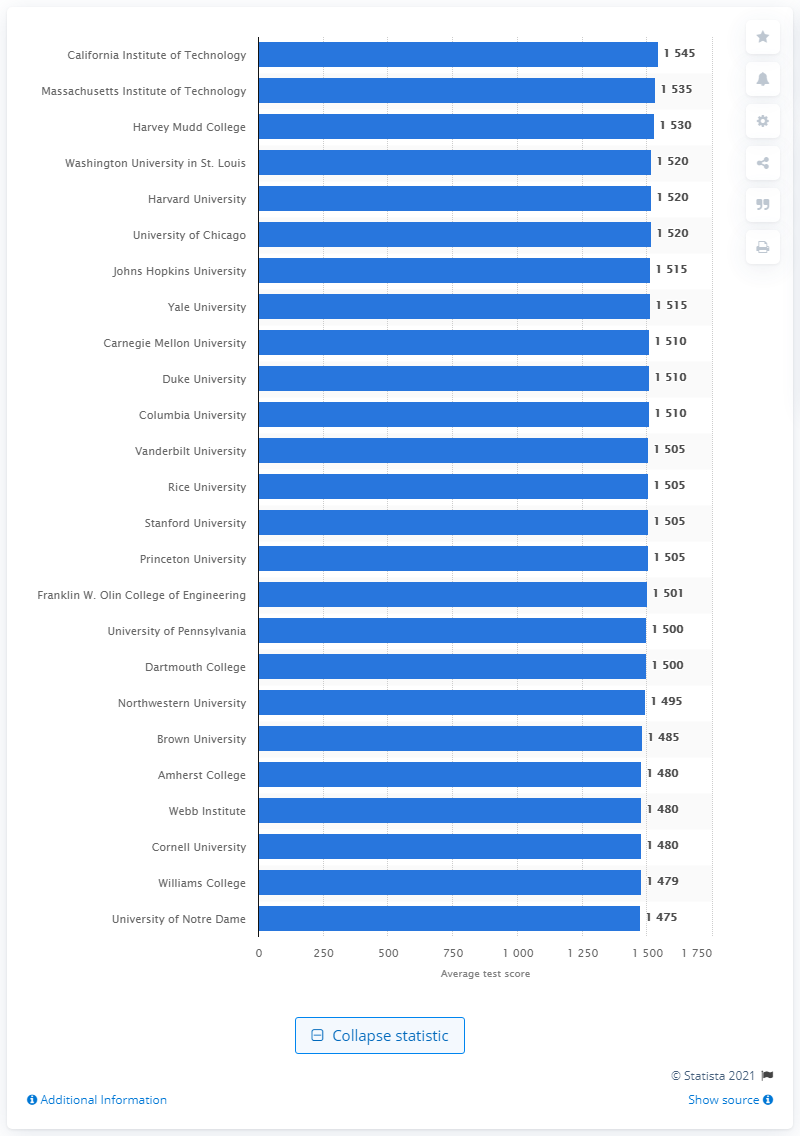Highlight a few significant elements in this photo. According to the data, the average SAT score of the California Institute of Technology was 1545. California Institute of Technology was considered the smartest college in the United States in 2020. 